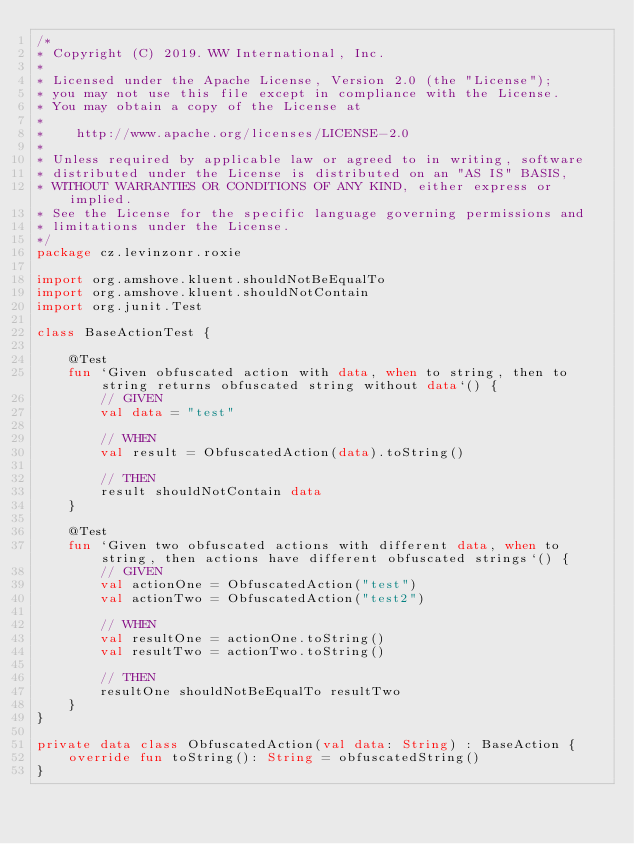<code> <loc_0><loc_0><loc_500><loc_500><_Kotlin_>/*
* Copyright (C) 2019. WW International, Inc.
*
* Licensed under the Apache License, Version 2.0 (the "License");
* you may not use this file except in compliance with the License.
* You may obtain a copy of the License at
*
*    http://www.apache.org/licenses/LICENSE-2.0
*
* Unless required by applicable law or agreed to in writing, software
* distributed under the License is distributed on an "AS IS" BASIS,
* WITHOUT WARRANTIES OR CONDITIONS OF ANY KIND, either express or implied.
* See the License for the specific language governing permissions and
* limitations under the License.
*/
package cz.levinzonr.roxie

import org.amshove.kluent.shouldNotBeEqualTo
import org.amshove.kluent.shouldNotContain
import org.junit.Test

class BaseActionTest {

    @Test
    fun `Given obfuscated action with data, when to string, then to string returns obfuscated string without data`() {
        // GIVEN
        val data = "test"

        // WHEN
        val result = ObfuscatedAction(data).toString()

        // THEN
        result shouldNotContain data
    }

    @Test
    fun `Given two obfuscated actions with different data, when to string, then actions have different obfuscated strings`() {
        // GIVEN
        val actionOne = ObfuscatedAction("test")
        val actionTwo = ObfuscatedAction("test2")

        // WHEN
        val resultOne = actionOne.toString()
        val resultTwo = actionTwo.toString()

        // THEN
        resultOne shouldNotBeEqualTo resultTwo
    }
}

private data class ObfuscatedAction(val data: String) : BaseAction {
    override fun toString(): String = obfuscatedString()
}
</code> 